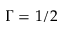<formula> <loc_0><loc_0><loc_500><loc_500>\Gamma = 1 / 2</formula> 